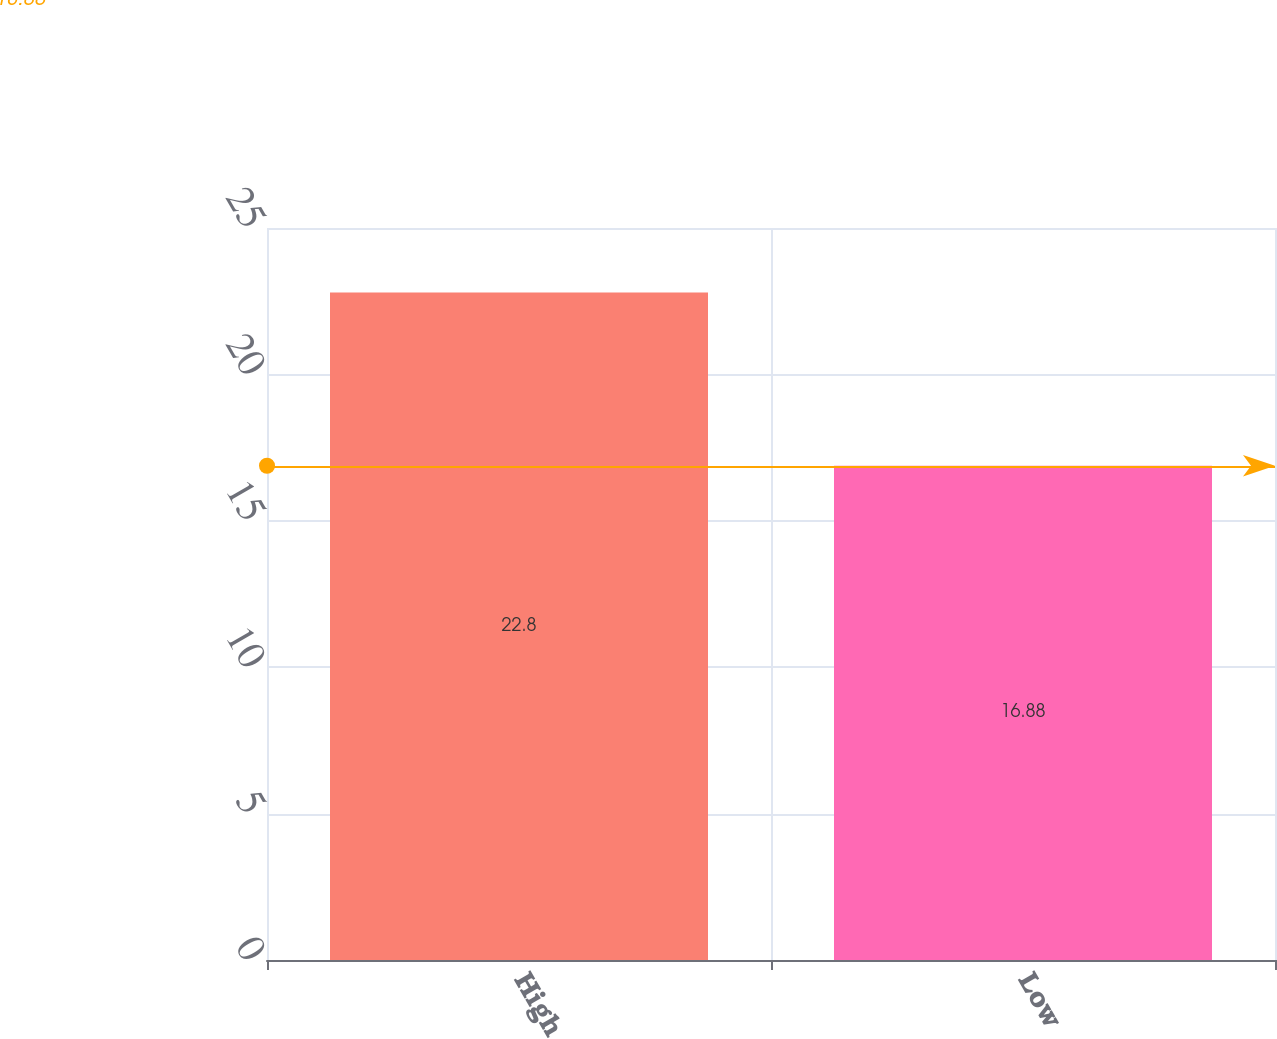Convert chart to OTSL. <chart><loc_0><loc_0><loc_500><loc_500><bar_chart><fcel>High<fcel>Low<nl><fcel>22.8<fcel>16.88<nl></chart> 